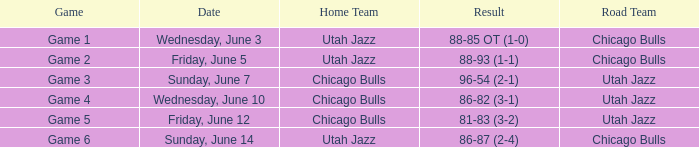The score 88-85 ot (1-0) corresponds to what game? Game 1. 